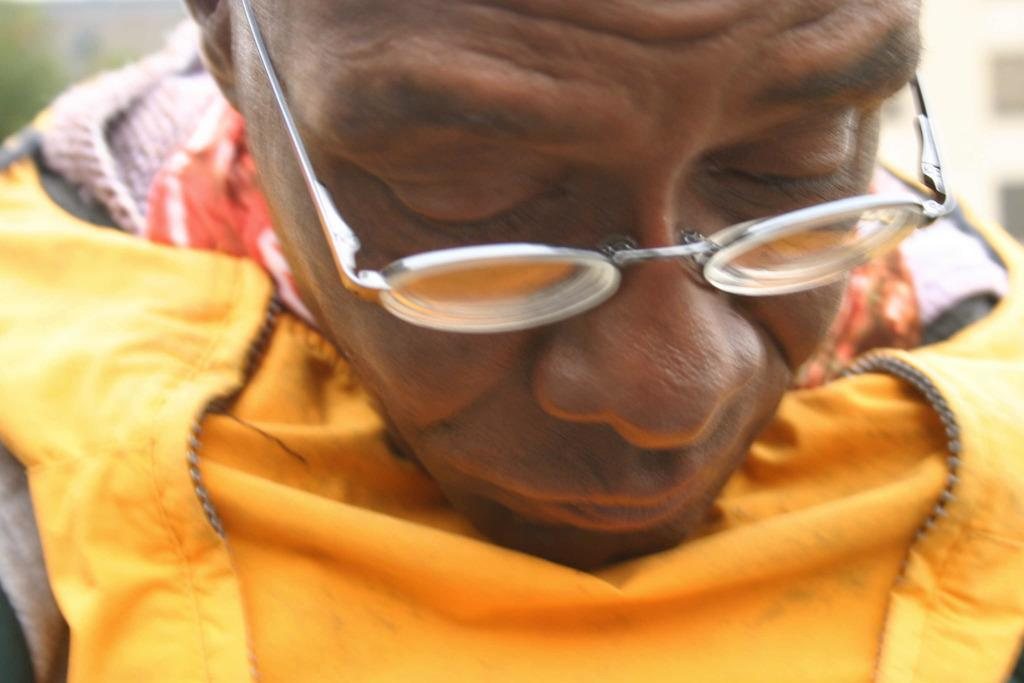Who is present in the image? There is a man in the image. What accessory is the man wearing? The man is wearing spectacles. What type of clothing can be seen towards the bottom of the image? There is a dress visible towards the bottom of the image. Can you describe the background of the image? The background of the image is blurred. How many cakes are being held by the dinosaurs in the image? There are no dinosaurs or cakes present in the image. 